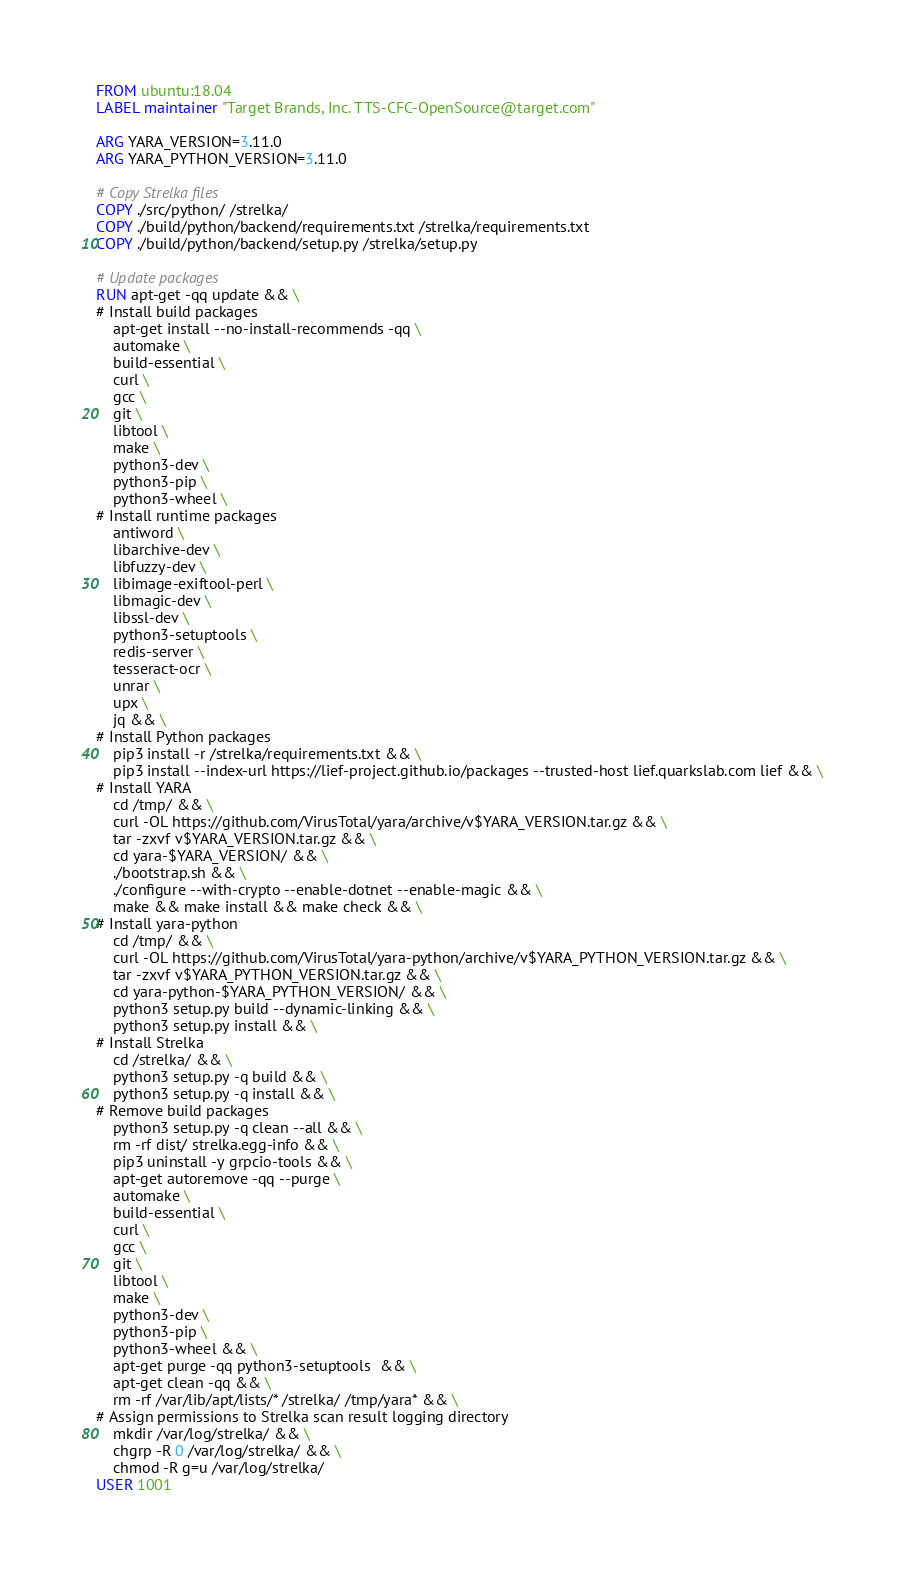Convert code to text. <code><loc_0><loc_0><loc_500><loc_500><_Dockerfile_>FROM ubuntu:18.04
LABEL maintainer "Target Brands, Inc. TTS-CFC-OpenSource@target.com"

ARG YARA_VERSION=3.11.0
ARG YARA_PYTHON_VERSION=3.11.0

# Copy Strelka files
COPY ./src/python/ /strelka/
COPY ./build/python/backend/requirements.txt /strelka/requirements.txt
COPY ./build/python/backend/setup.py /strelka/setup.py

# Update packages
RUN apt-get -qq update && \
# Install build packages
    apt-get install --no-install-recommends -qq \
    automake \
    build-essential \
    curl \
    gcc \
    git \
    libtool \
    make \
    python3-dev \
    python3-pip \
    python3-wheel \
# Install runtime packages
    antiword \
    libarchive-dev \
    libfuzzy-dev \
    libimage-exiftool-perl \
    libmagic-dev \
    libssl-dev \
    python3-setuptools \
    redis-server \
    tesseract-ocr \
    unrar \
    upx \
    jq && \
# Install Python packages
    pip3 install -r /strelka/requirements.txt && \
    pip3 install --index-url https://lief-project.github.io/packages --trusted-host lief.quarkslab.com lief && \
# Install YARA
    cd /tmp/ && \
    curl -OL https://github.com/VirusTotal/yara/archive/v$YARA_VERSION.tar.gz && \
    tar -zxvf v$YARA_VERSION.tar.gz && \
    cd yara-$YARA_VERSION/ && \
    ./bootstrap.sh && \
    ./configure --with-crypto --enable-dotnet --enable-magic && \
    make && make install && make check && \
# Install yara-python
    cd /tmp/ && \
    curl -OL https://github.com/VirusTotal/yara-python/archive/v$YARA_PYTHON_VERSION.tar.gz && \
    tar -zxvf v$YARA_PYTHON_VERSION.tar.gz && \
    cd yara-python-$YARA_PYTHON_VERSION/ && \
    python3 setup.py build --dynamic-linking && \
    python3 setup.py install && \
# Install Strelka
    cd /strelka/ && \
    python3 setup.py -q build && \
    python3 setup.py -q install && \
# Remove build packages
    python3 setup.py -q clean --all && \
    rm -rf dist/ strelka.egg-info && \
    pip3 uninstall -y grpcio-tools && \
    apt-get autoremove -qq --purge \
    automake \
    build-essential \
    curl \
    gcc \
    git \
    libtool \
    make \
    python3-dev \
    python3-pip \
    python3-wheel && \
    apt-get purge -qq python3-setuptools  && \
    apt-get clean -qq && \
    rm -rf /var/lib/apt/lists/* /strelka/ /tmp/yara* && \
# Assign permissions to Strelka scan result logging directory
    mkdir /var/log/strelka/ && \
    chgrp -R 0 /var/log/strelka/ && \
    chmod -R g=u /var/log/strelka/
USER 1001
</code> 